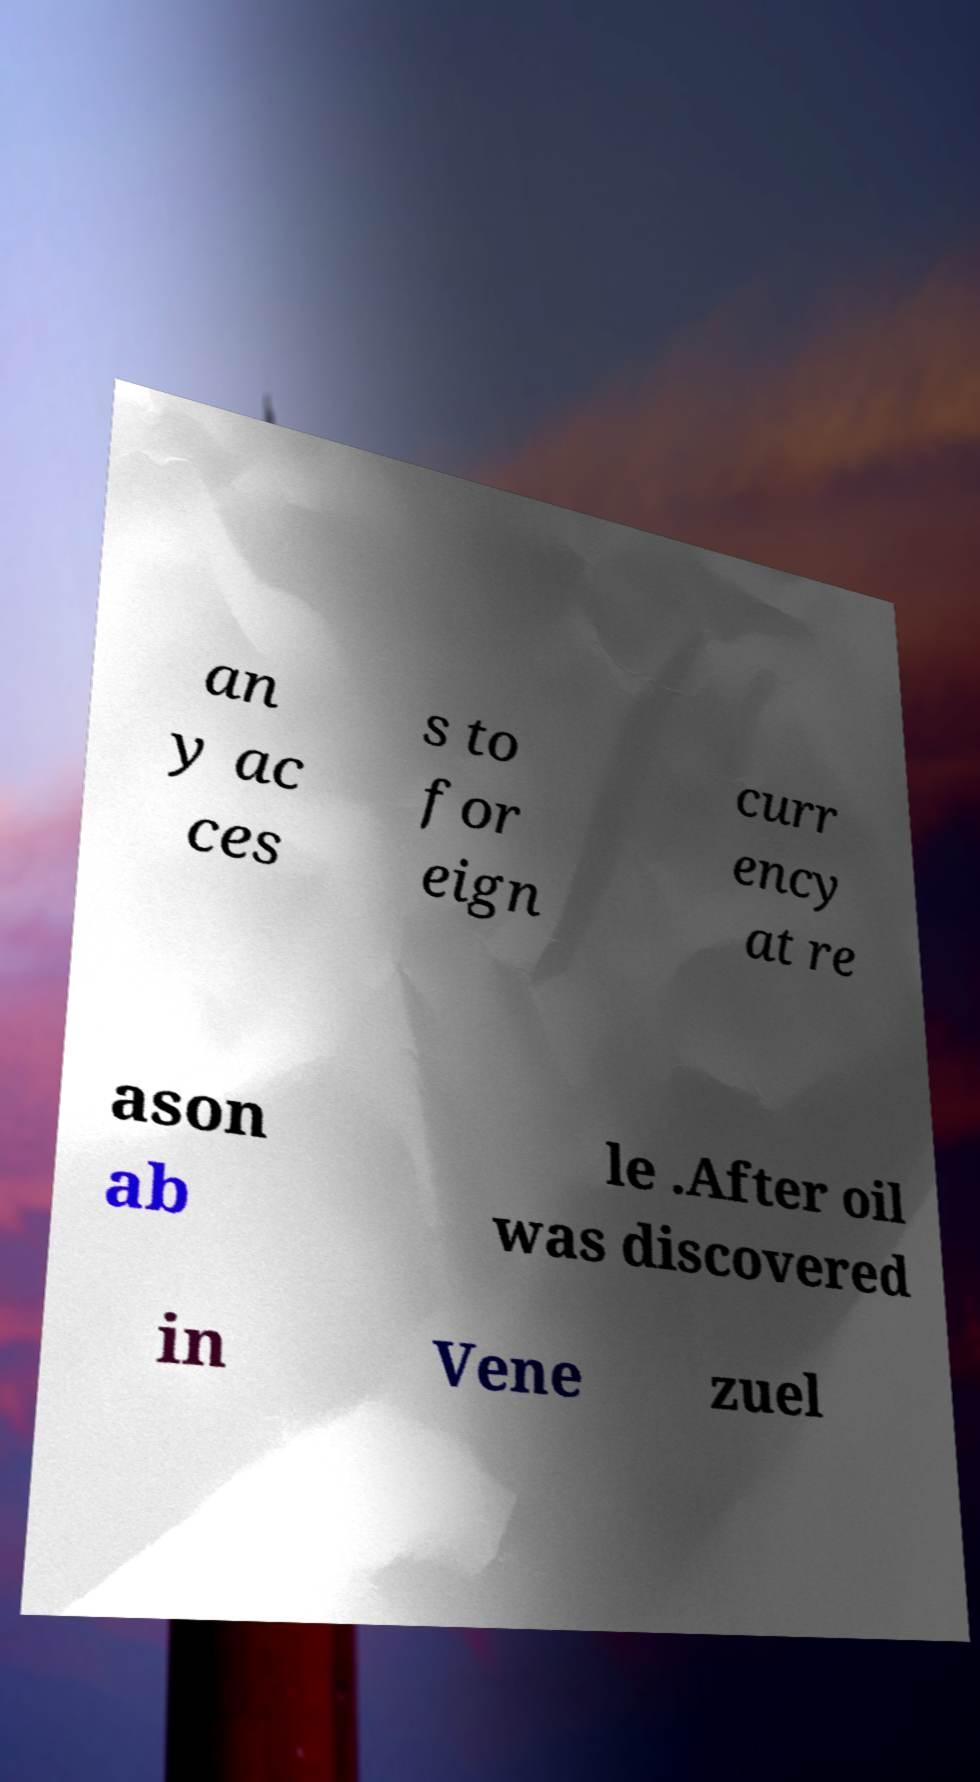Can you accurately transcribe the text from the provided image for me? an y ac ces s to for eign curr ency at re ason ab le .After oil was discovered in Vene zuel 